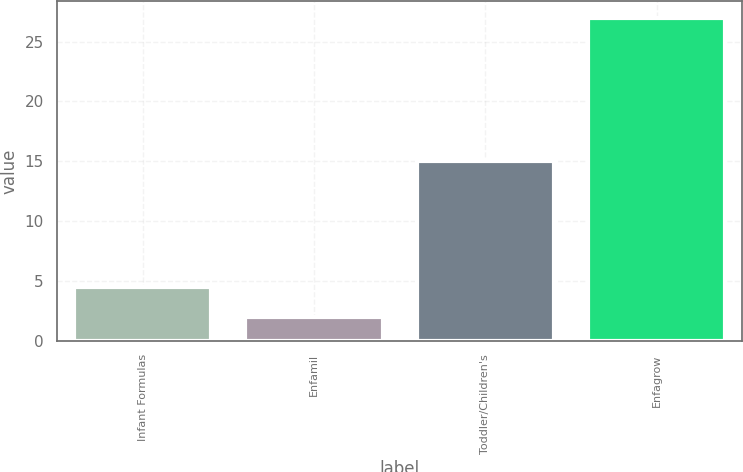<chart> <loc_0><loc_0><loc_500><loc_500><bar_chart><fcel>Infant Formulas<fcel>Enfamil<fcel>Toddler/Children's<fcel>Enfagrow<nl><fcel>4.5<fcel>2<fcel>15<fcel>27<nl></chart> 